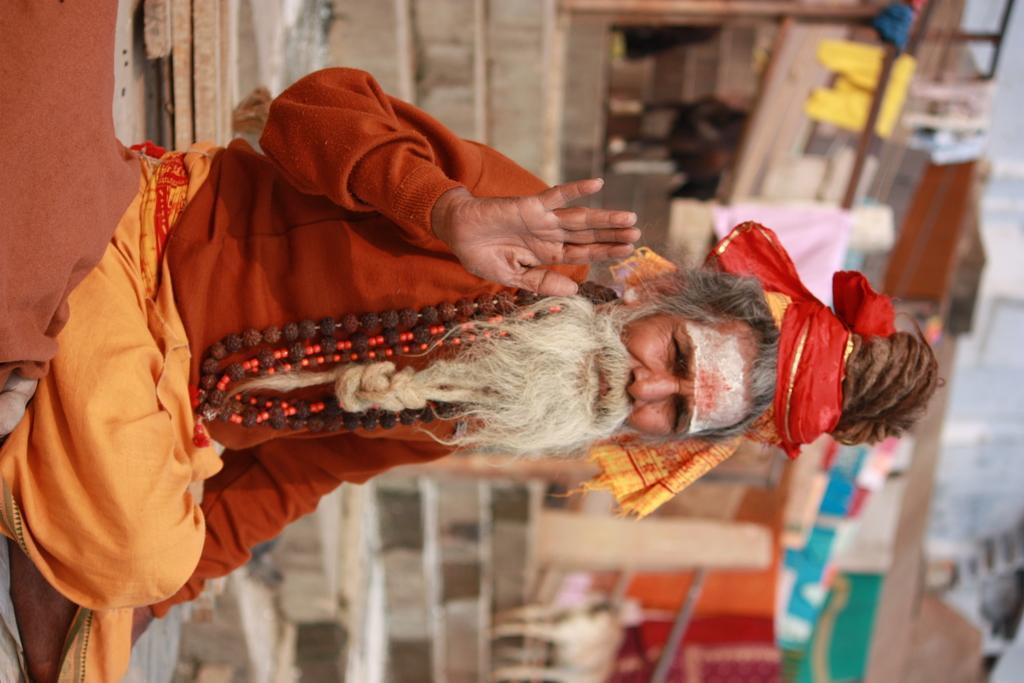How would you summarize this image in a sentence or two? Here in this picture we can see an old Hindu saint sitting on the steps present over there and we can see he is wearing some chains on him and behind him we can see steps present and we can see some shops present here and there. 